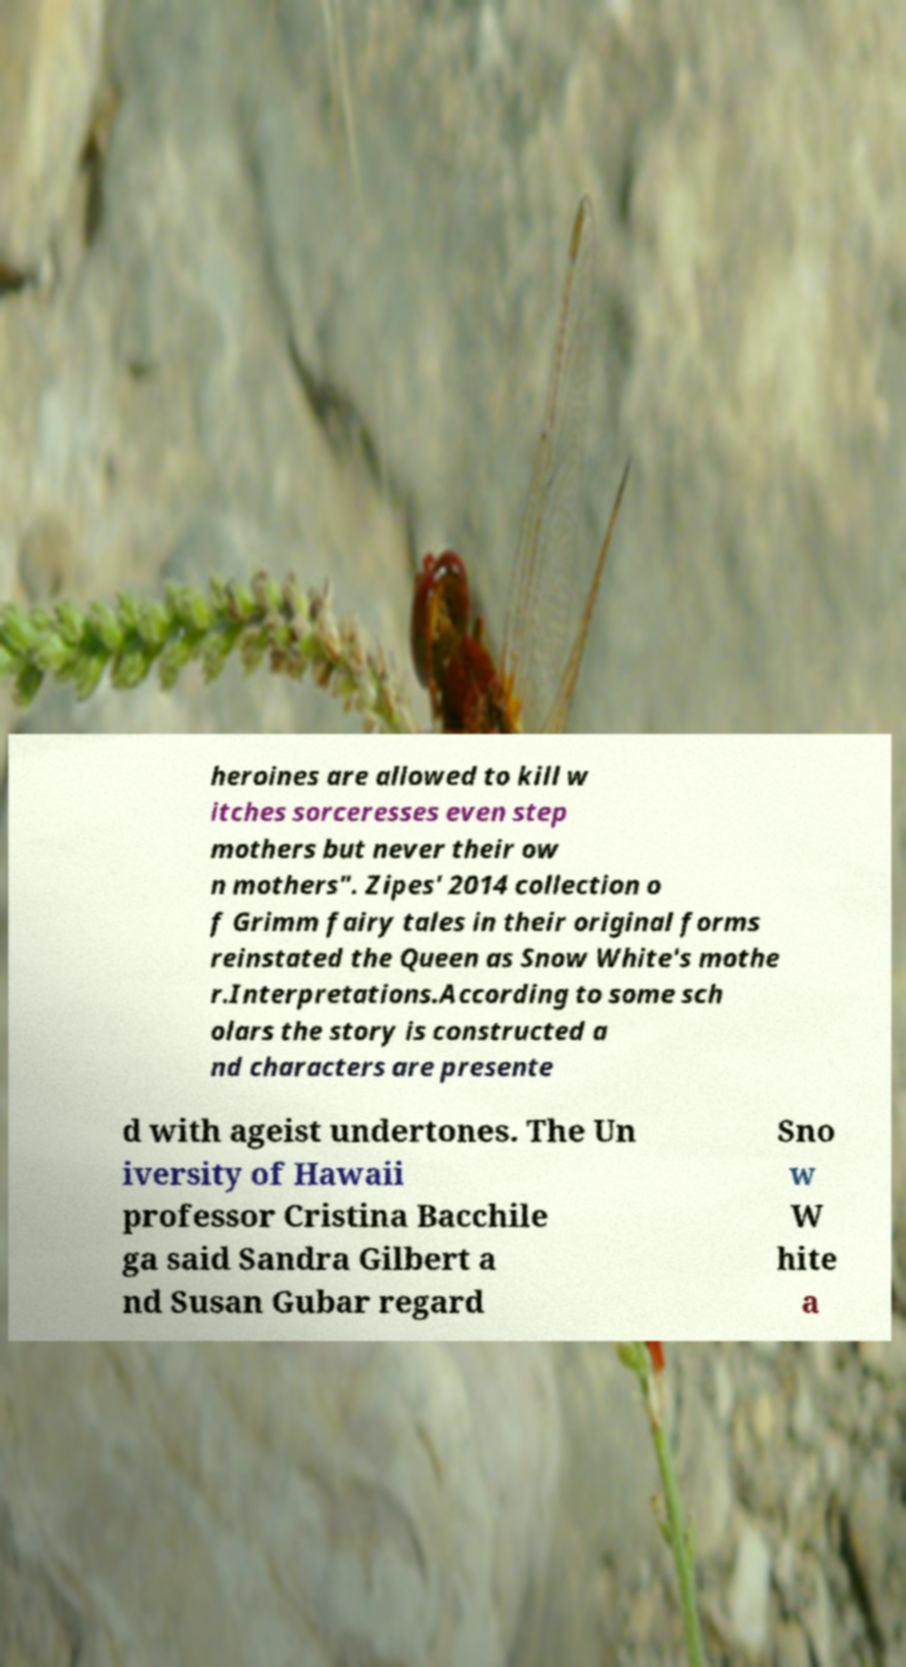What messages or text are displayed in this image? I need them in a readable, typed format. heroines are allowed to kill w itches sorceresses even step mothers but never their ow n mothers". Zipes' 2014 collection o f Grimm fairy tales in their original forms reinstated the Queen as Snow White's mothe r.Interpretations.According to some sch olars the story is constructed a nd characters are presente d with ageist undertones. The Un iversity of Hawaii professor Cristina Bacchile ga said Sandra Gilbert a nd Susan Gubar regard Sno w W hite a 